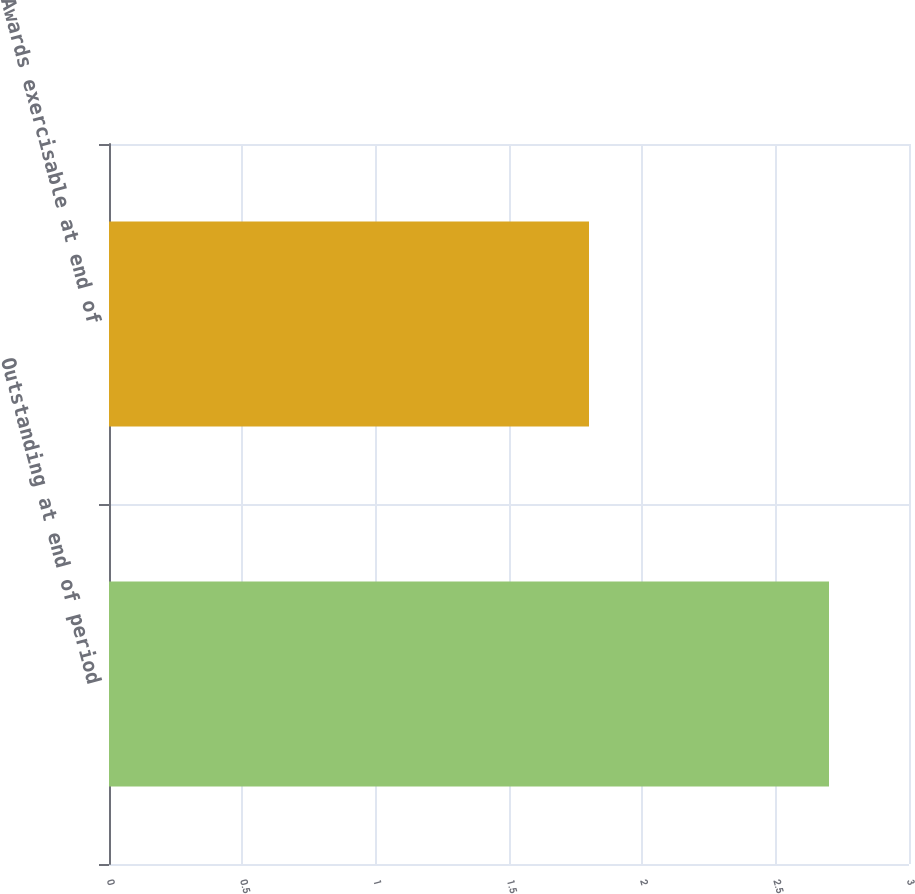Convert chart to OTSL. <chart><loc_0><loc_0><loc_500><loc_500><bar_chart><fcel>Outstanding at end of period<fcel>Awards exercisable at end of<nl><fcel>2.7<fcel>1.8<nl></chart> 